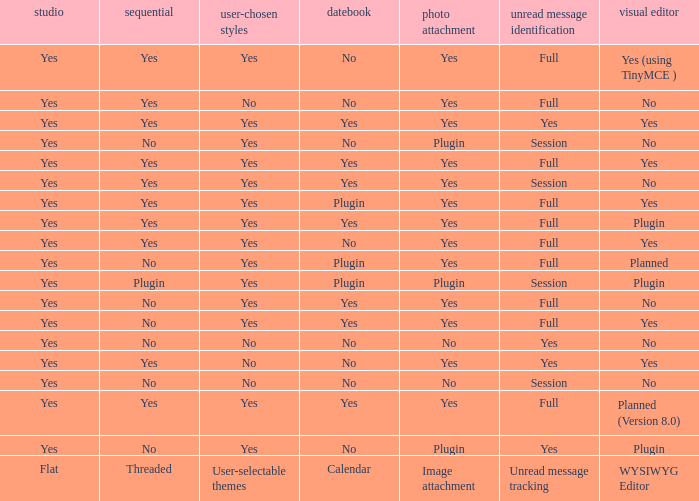Which Calendar has WYSIWYG Editor of yes and an Unread message tracking of yes? Yes, No. 